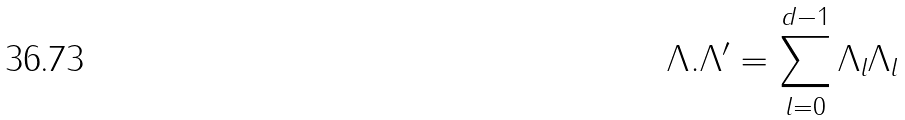Convert formula to latex. <formula><loc_0><loc_0><loc_500><loc_500>\Lambda . \Lambda ^ { \prime } = \sum _ { l = 0 } ^ { d - 1 } \Lambda _ { l } \Lambda _ { l }</formula> 